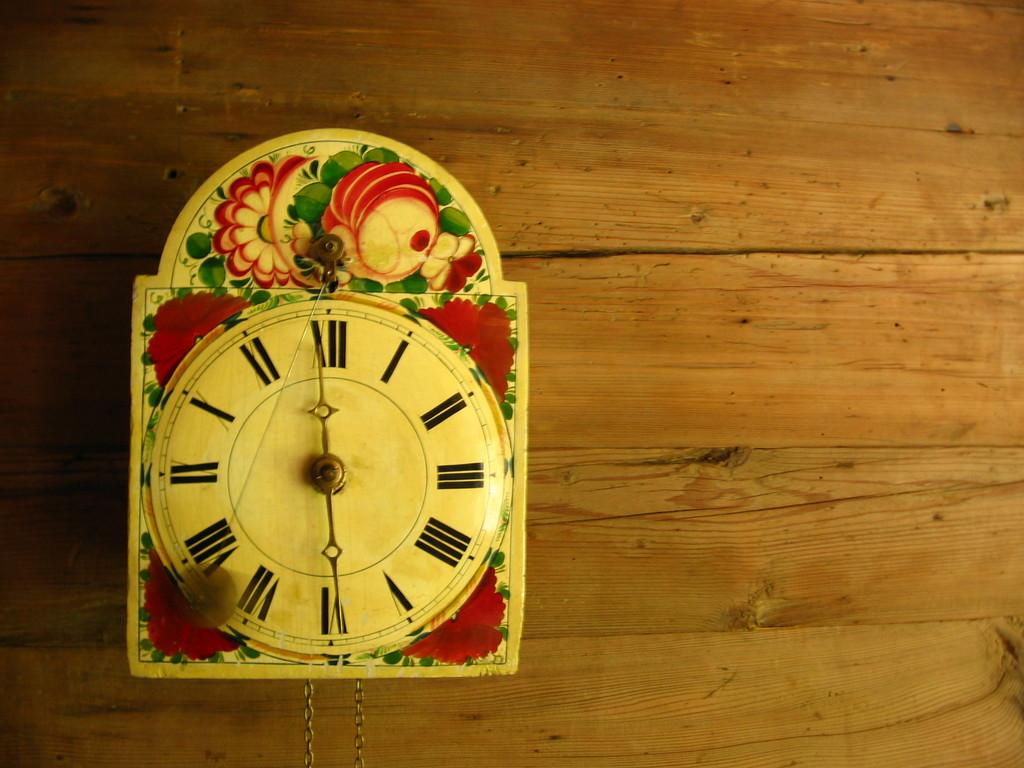Provide a one-sentence caption for the provided image. A clock whose hands show it is about to be six. 